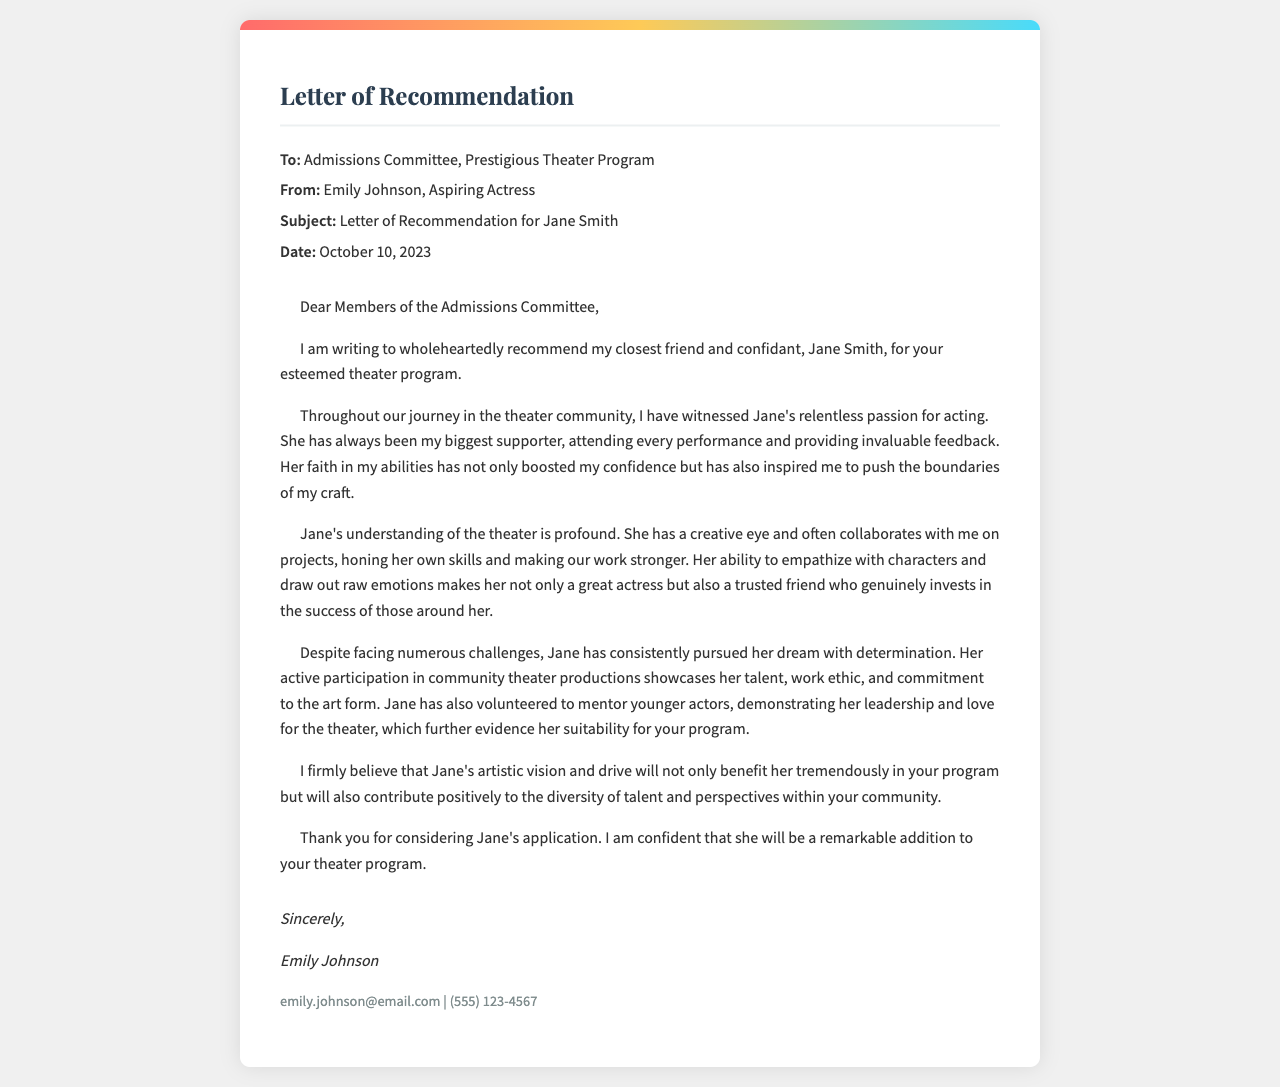What is the title of the document? The title appears at the top of the document and indicates its purpose.
Answer: Letter of Recommendation Who is the letter addressed to? The document specifies the recipient in the header section.
Answer: Admissions Committee, Prestigious Theater Program Who is the sender of the letter? The sender's name is mentioned right below the recipient in the header.
Answer: Emily Johnson What is the date of the letter? The date is provided in the header section of the document.
Answer: October 10, 2023 What quality of Jane Smith is emphasized in the letter? The recommendation details qualities that set Jane apart as a candidate.
Answer: Relentless passion for acting What role does Jane Smith play in Emily's journey? The relationship between Emily and Jane is highlighted throughout the letter.
Answer: Closest friend and confidant How does Jane contribute to community theater? The letter mentions Jane's involvement and qualities relevant to theater.
Answer: Active participation in productions What kind of projects does Jane work on with Emily? This indicates Jane's collaborative nature and artistic involvement.
Answer: Collaborative projects What does Emily believe Jane will contribute to the program? Emily's opinion about Jane's potential impact is stated in the recommendation.
Answer: Diversity of talent and perspectives 